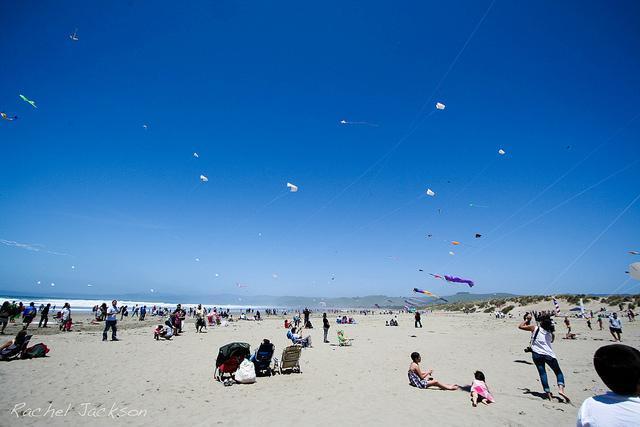How many black cat are this image?
Give a very brief answer. 0. 